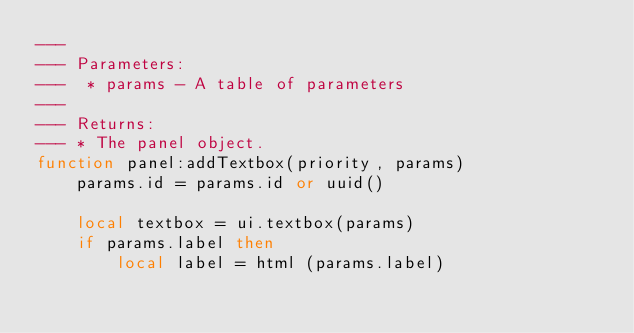Convert code to text. <code><loc_0><loc_0><loc_500><loc_500><_Lua_>---
--- Parameters:
---  * params - A table of parameters
---
--- Returns:
--- * The panel object.
function panel:addTextbox(priority, params)
    params.id = params.id or uuid()

    local textbox = ui.textbox(params)
    if params.label then
        local label = html (params.label)</code> 